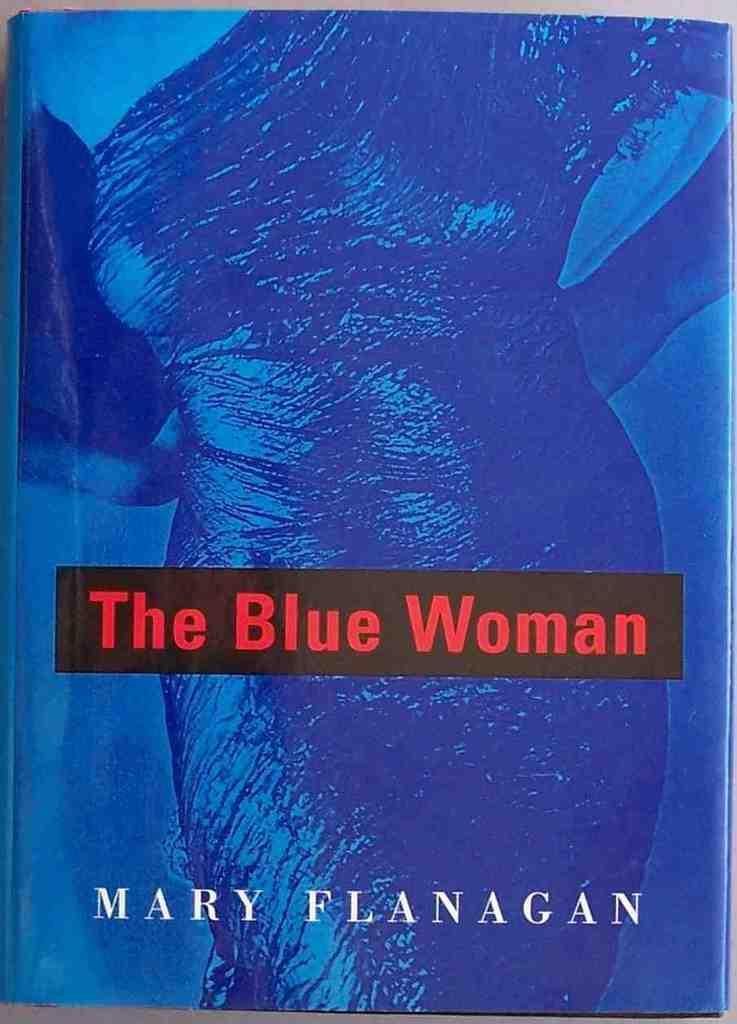Could you give a brief overview of what you see in this image? This image consists of a book. The book is in blue color and on this I can see a person and some text. 